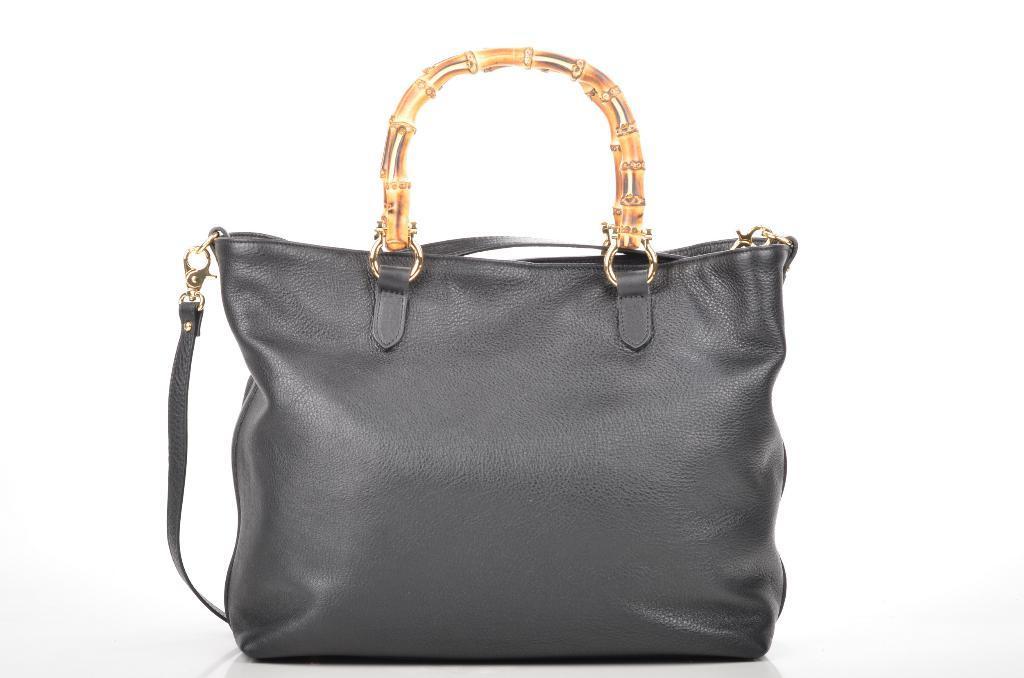Could you give a brief overview of what you see in this image? In the image we can see there is a purse which is in ash colour and the handle is in golden colour. 